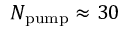Convert formula to latex. <formula><loc_0><loc_0><loc_500><loc_500>N _ { p u m p } \approx 3 0</formula> 